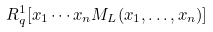Convert formula to latex. <formula><loc_0><loc_0><loc_500><loc_500>R _ { q } ^ { 1 } [ x _ { 1 } \cdots x _ { n } M _ { L } ( x _ { 1 } , \dots , x _ { n } ) ]</formula> 